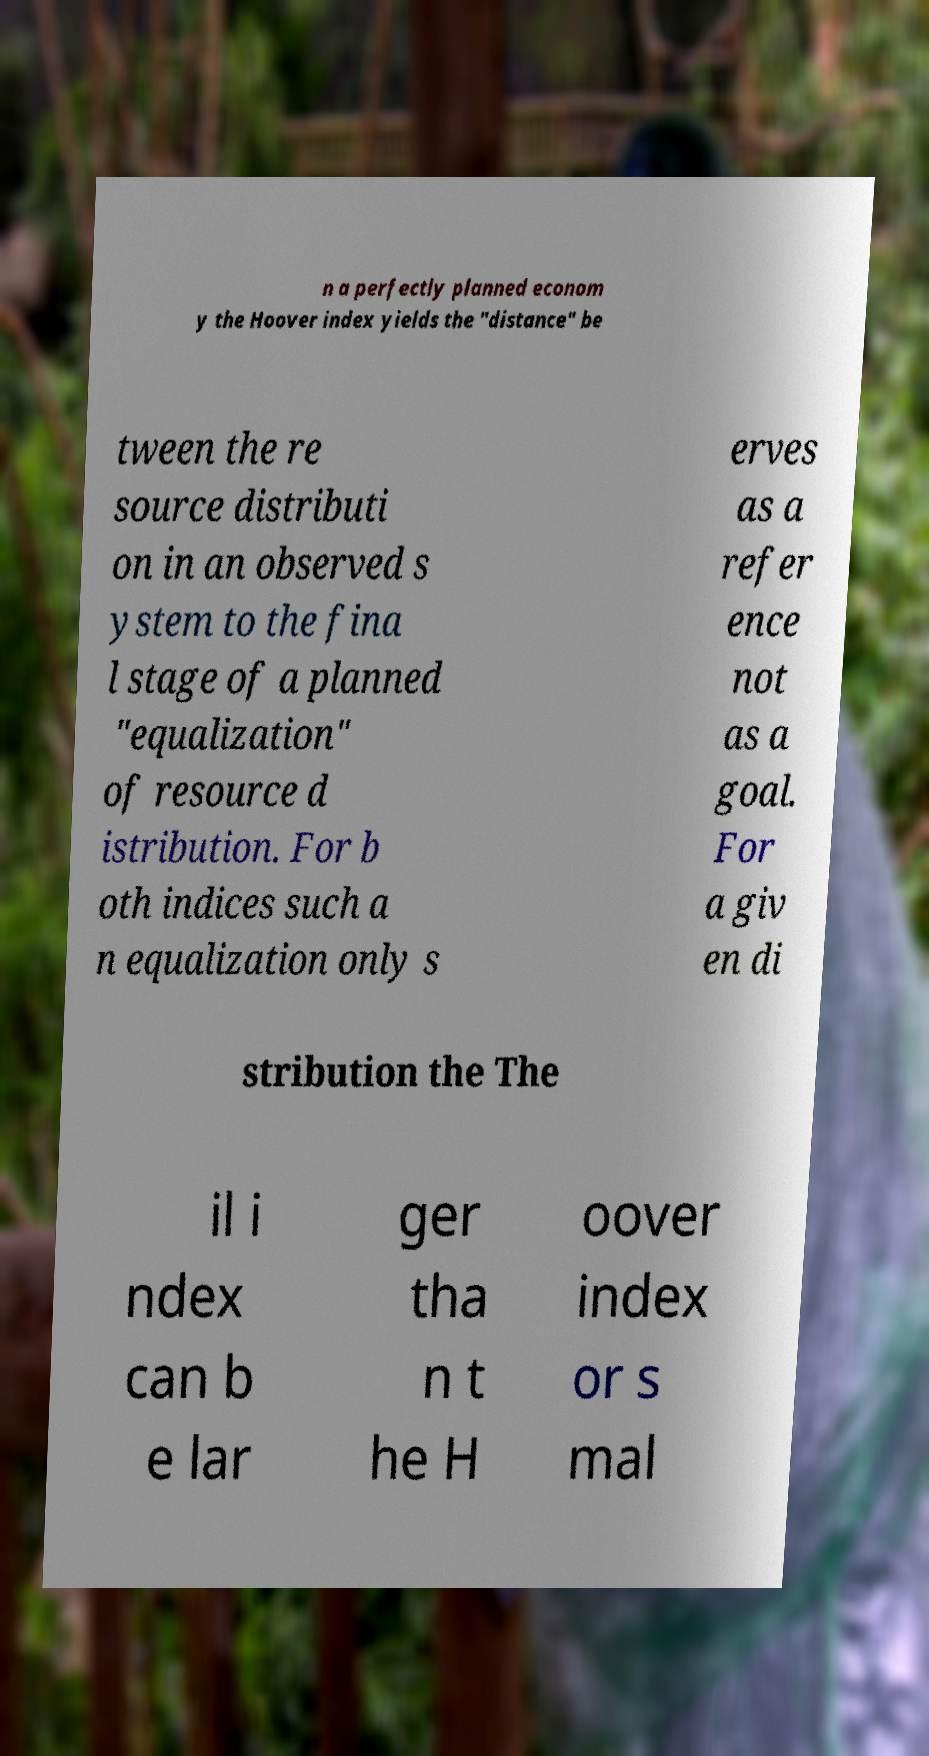Please identify and transcribe the text found in this image. n a perfectly planned econom y the Hoover index yields the "distance" be tween the re source distributi on in an observed s ystem to the fina l stage of a planned "equalization" of resource d istribution. For b oth indices such a n equalization only s erves as a refer ence not as a goal. For a giv en di stribution the The il i ndex can b e lar ger tha n t he H oover index or s mal 